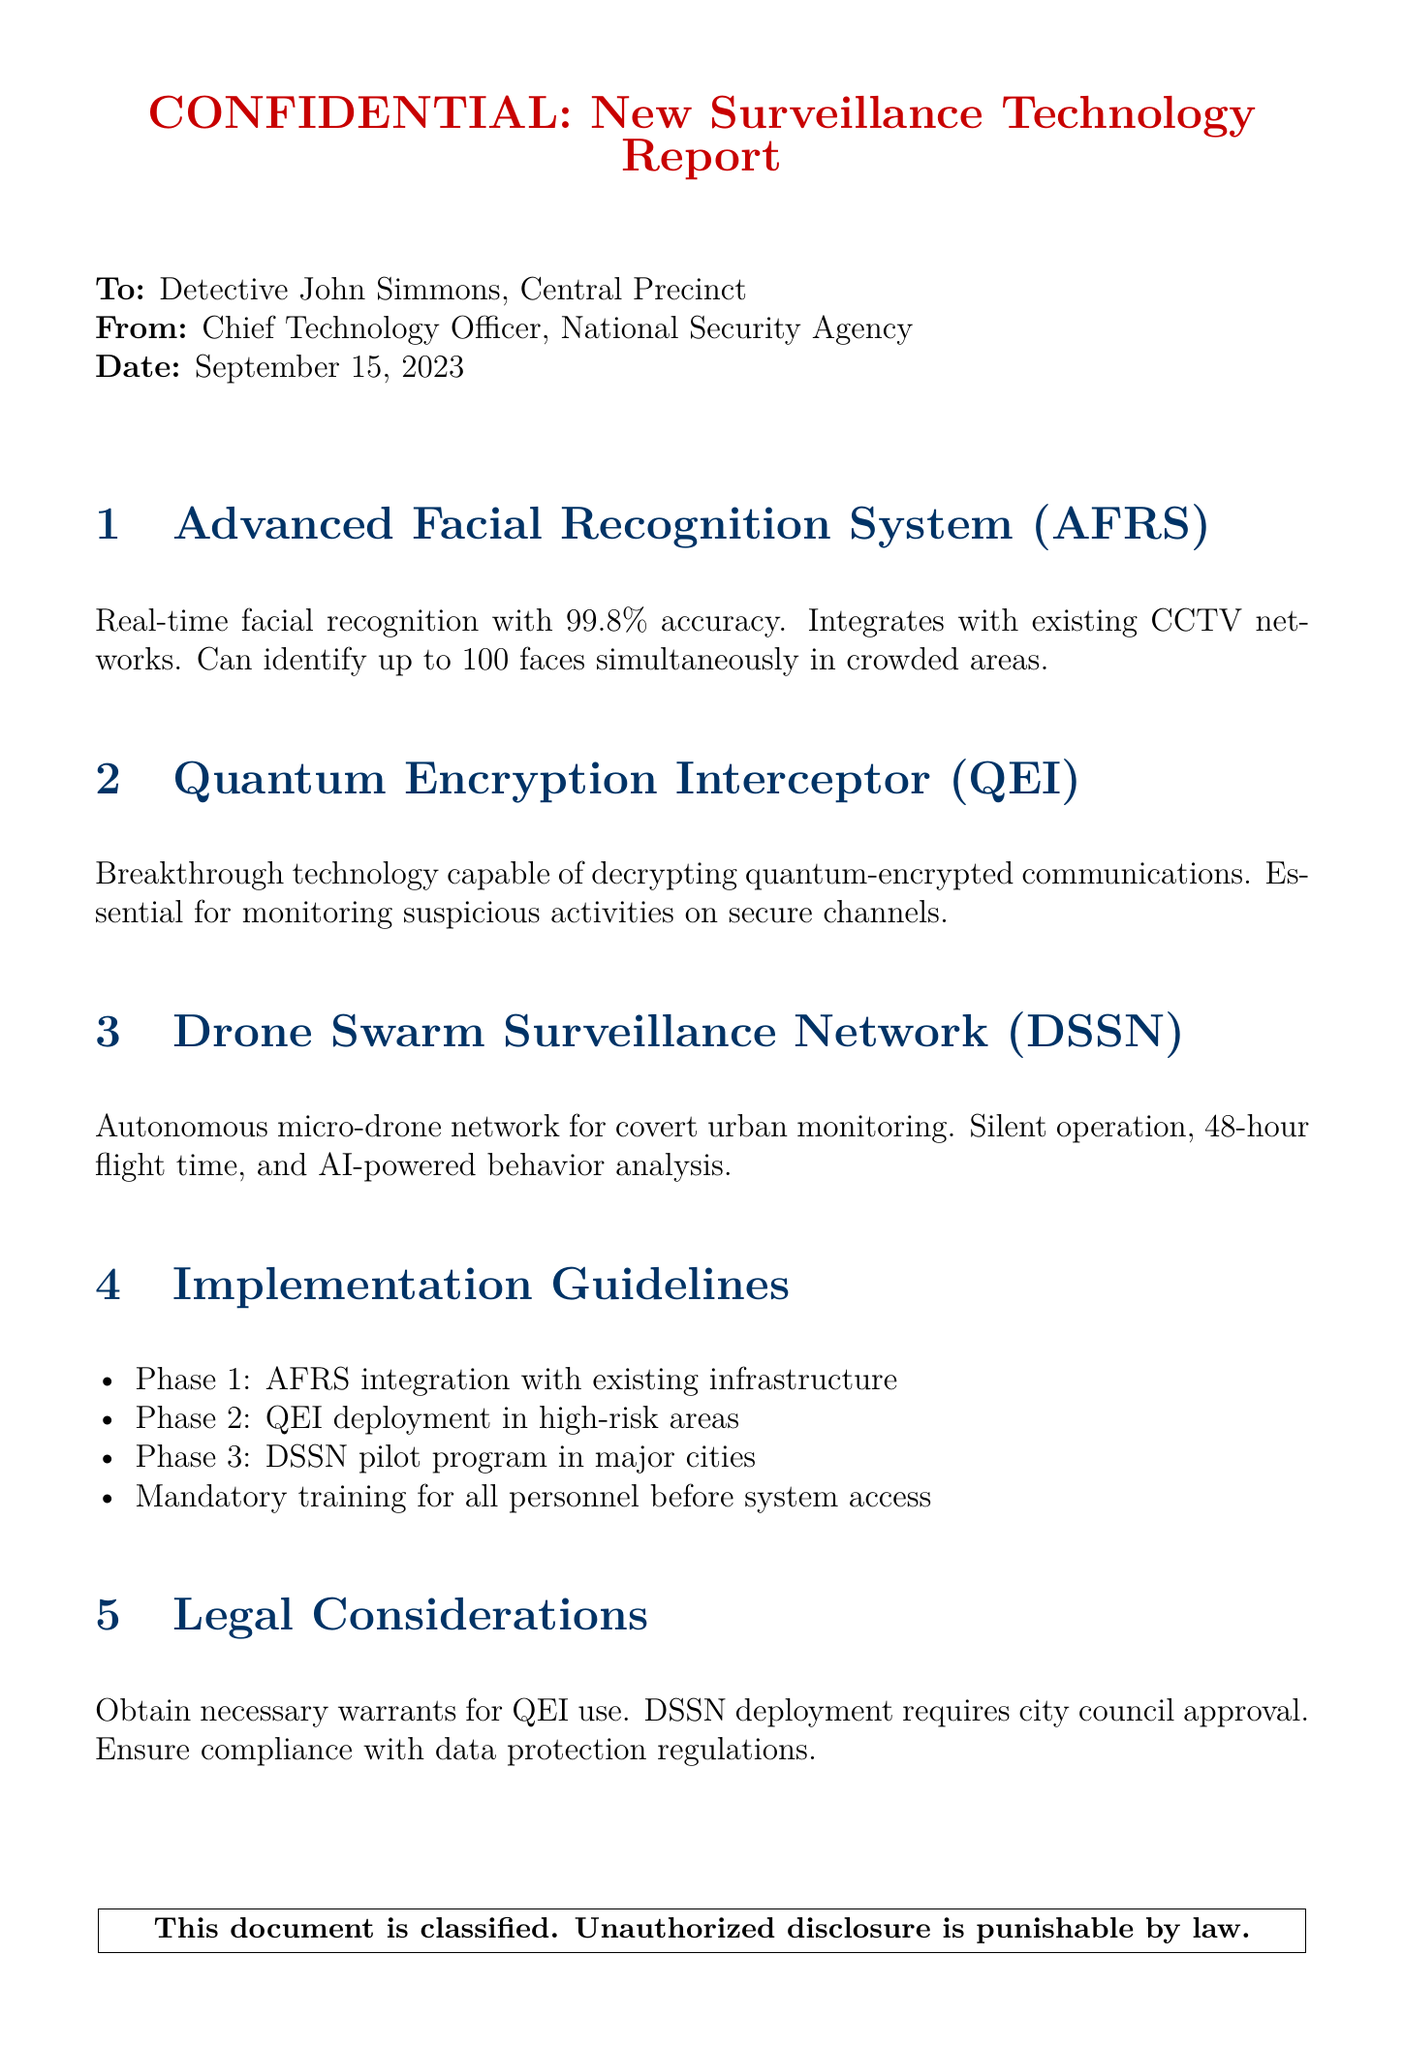What is the date of the report? The date is mentioned at the top of the document under the date section, which is September 15, 2023.
Answer: September 15, 2023 Who is the report addressed to? The report is directed to Detective John Simmons, as stated at the beginning of the document.
Answer: Detective John Simmons What is the accuracy percentage of the Advanced Facial Recognition System? The accuracy percentage is provided in the section about AFRS, which states it is 99.8%.
Answer: 99.8% What phase involves QEI deployment? The document lists phases of implementation, and QEI deployment is in Phase 2.
Answer: Phase 2 What requires city council approval? The legal considerations section mentions that DSSN deployment requires city council approval.
Answer: DSSN deployment How many faces can the AFRS identify simultaneously? The AFRS section specifies that it can identify up to 100 faces simultaneously.
Answer: 100 faces What technology is capable of decrypting quantum-encrypted communications? The report refers to the Quantum Encryption Interceptor (QEI) as the technology that can do this.
Answer: Quantum Encryption Interceptor (QEI) What is the flight time of the drones in the DSSN? The report specifies that the drones have a flight time of 48 hours.
Answer: 48 hours What is the focus of Phase 1 in the implementation guidelines? The first phase mentioned is about integrating the AFRS with existing infrastructure.
Answer: AFRS integration with existing infrastructure 